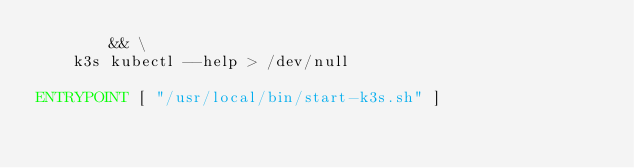<code> <loc_0><loc_0><loc_500><loc_500><_Dockerfile_>        && \
    k3s kubectl --help > /dev/null

ENTRYPOINT [ "/usr/local/bin/start-k3s.sh" ]
</code> 